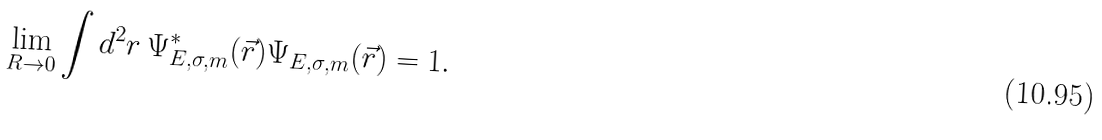Convert formula to latex. <formula><loc_0><loc_0><loc_500><loc_500>\lim _ { R \to 0 } \int d ^ { 2 } r \, \Psi ^ { * } _ { E , \sigma , m } ( \vec { r } ) \Psi _ { E , \sigma , m } ( \vec { r } ) = 1 .</formula> 